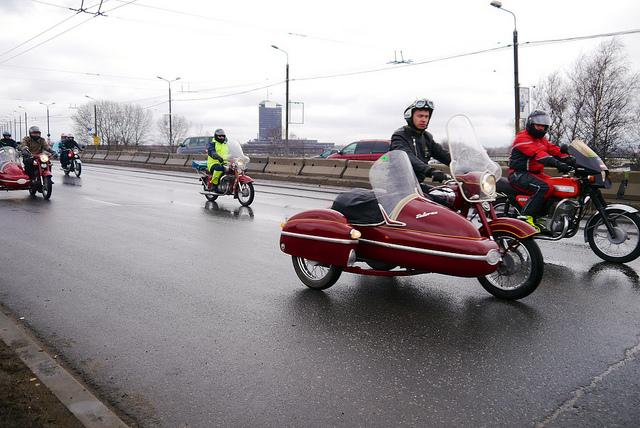What could have made the road appear shiny? rain 